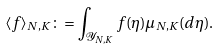Convert formula to latex. <formula><loc_0><loc_0><loc_500><loc_500>\langle f \rangle _ { N , K } \colon = \int _ { \mathcal { Y } _ { N , K } } f ( \eta ) \mu _ { N , K } ( d \eta ) .</formula> 